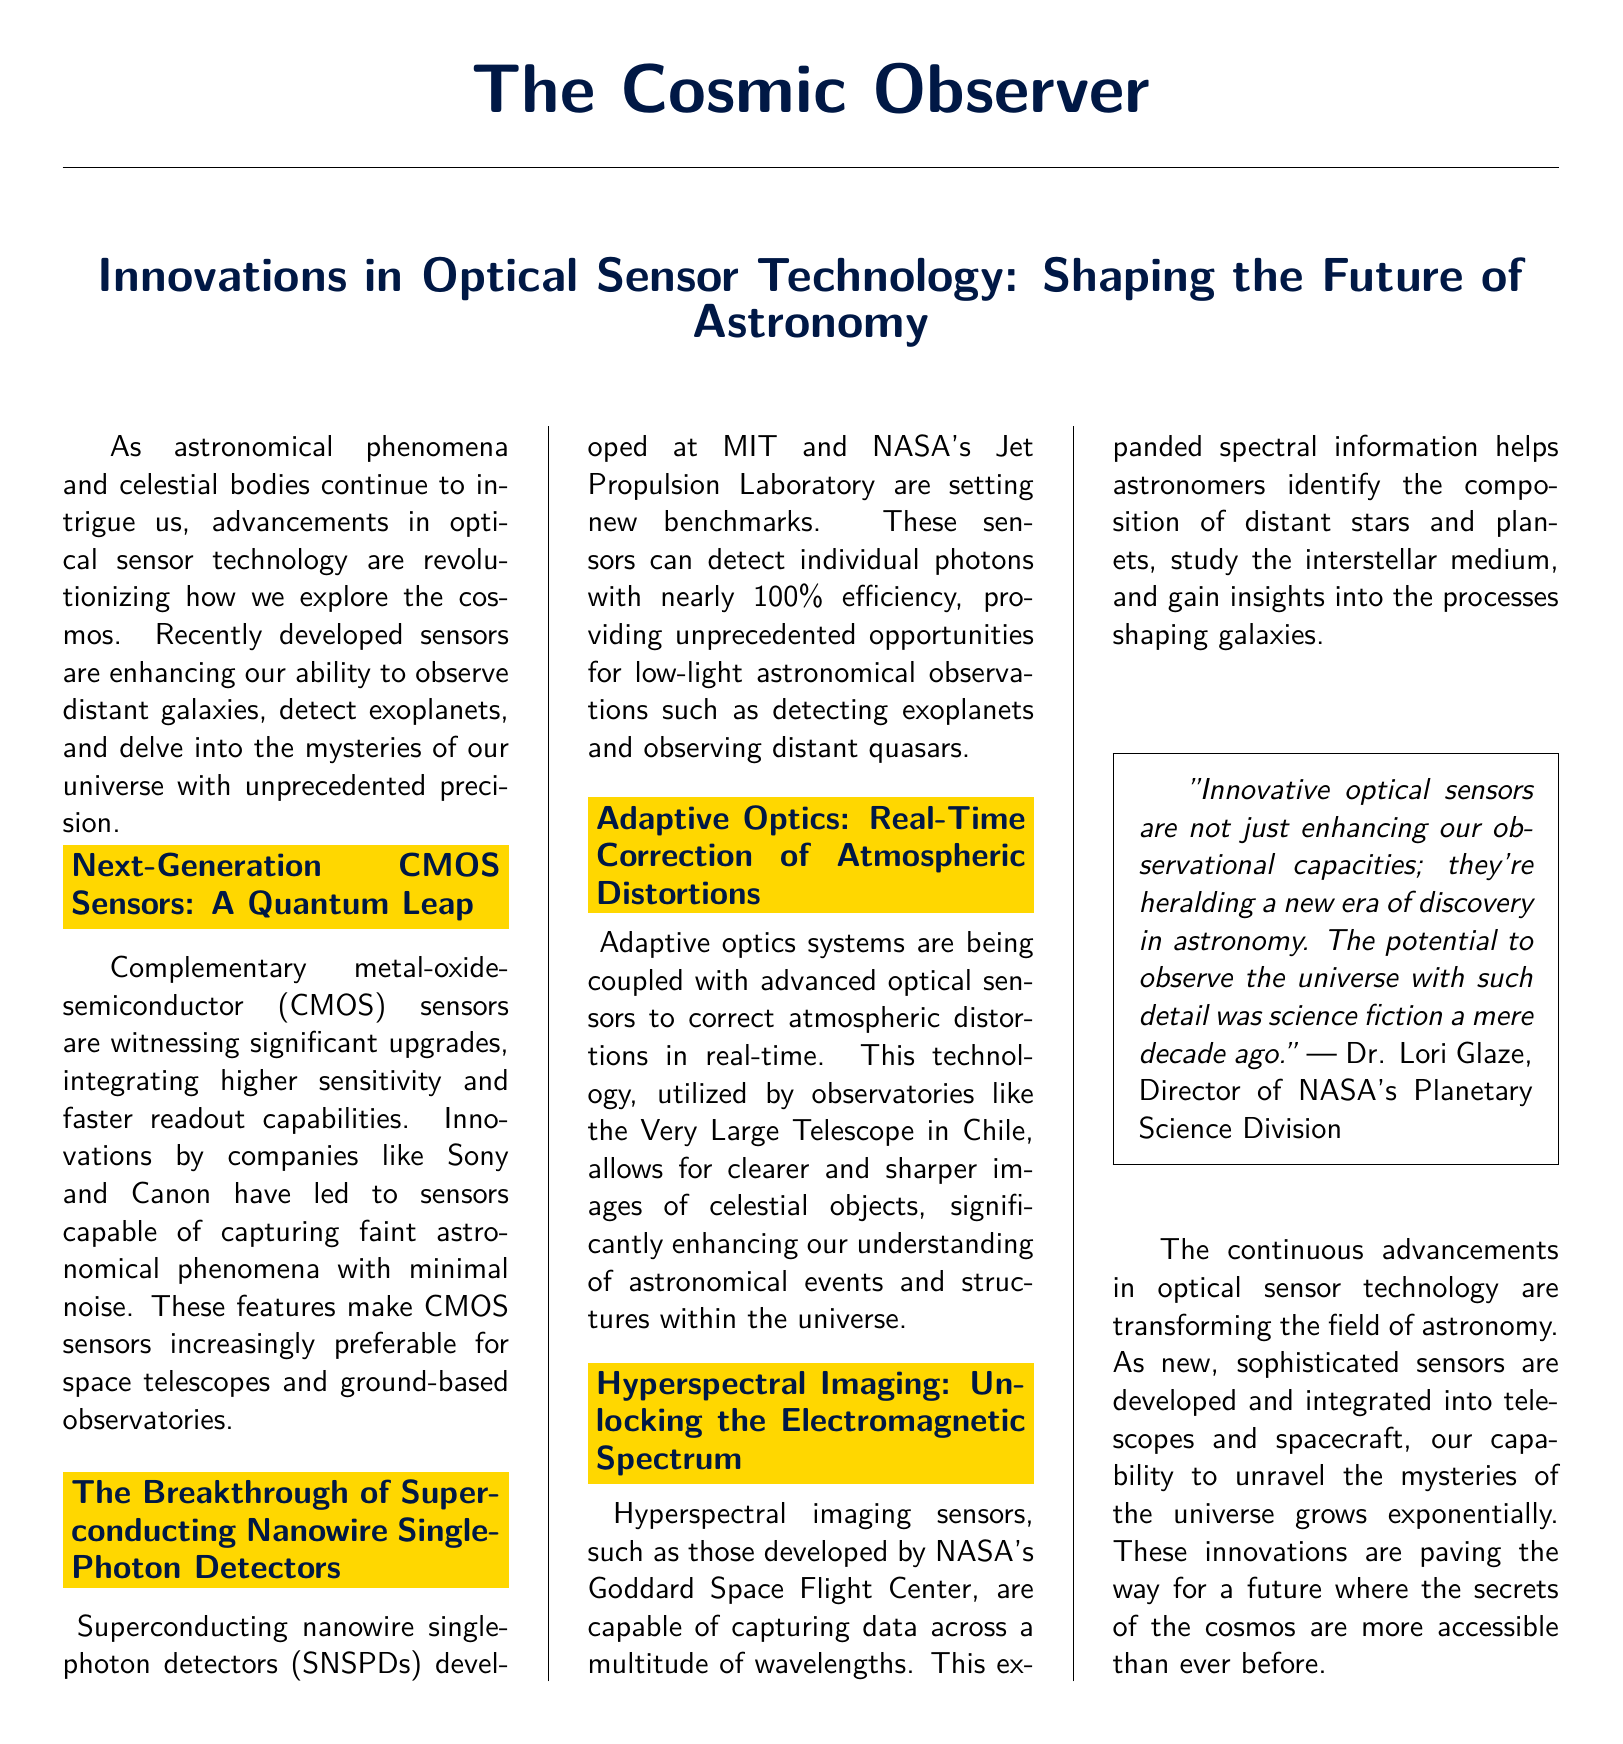What are CMOS sensors witnessing? The section discusses significant upgrades in CMOS sensors, focusing on their evolving capabilities.
Answer: Significant upgrades What companies are mentioned in relation to CMOS sensors? The document specifies Sony and Canon as key players in upgrading CMOS sensors.
Answer: Sony and Canon What is the efficiency rate of superconducting nanowire single-photon detectors? The document states that these sensors can detect individual photons with nearly 100% efficiency.
Answer: Nearly 100% Which telescope is mentioned in connection with adaptive optics? The text mentions the Very Large Telescope in Chile as a facility utilizing adaptive optics systems.
Answer: Very Large Telescope What kind of imaging capability do hyperspectral imaging sensors possess? The document notes that hyperspectral imaging sensors can capture data across a multitude of wavelengths.
Answer: Multitude of wavelengths What is a key benefit of enhanced optical sensors according to Dr. Lori Glaze? The quoted statement emphasizes that innovative optical sensors are heralding a new era of discovery in astronomy.
Answer: A new era of discovery Why are optical sensors important for astronomy? The document explains that advancements in optical sensor technology enhance our ability to observe the cosmos.
Answer: Enhance our ability to observe the cosmos What kind of document is "The Cosmic Observer"? The layout indicates this is a newspaper document.
Answer: Newspaper document 